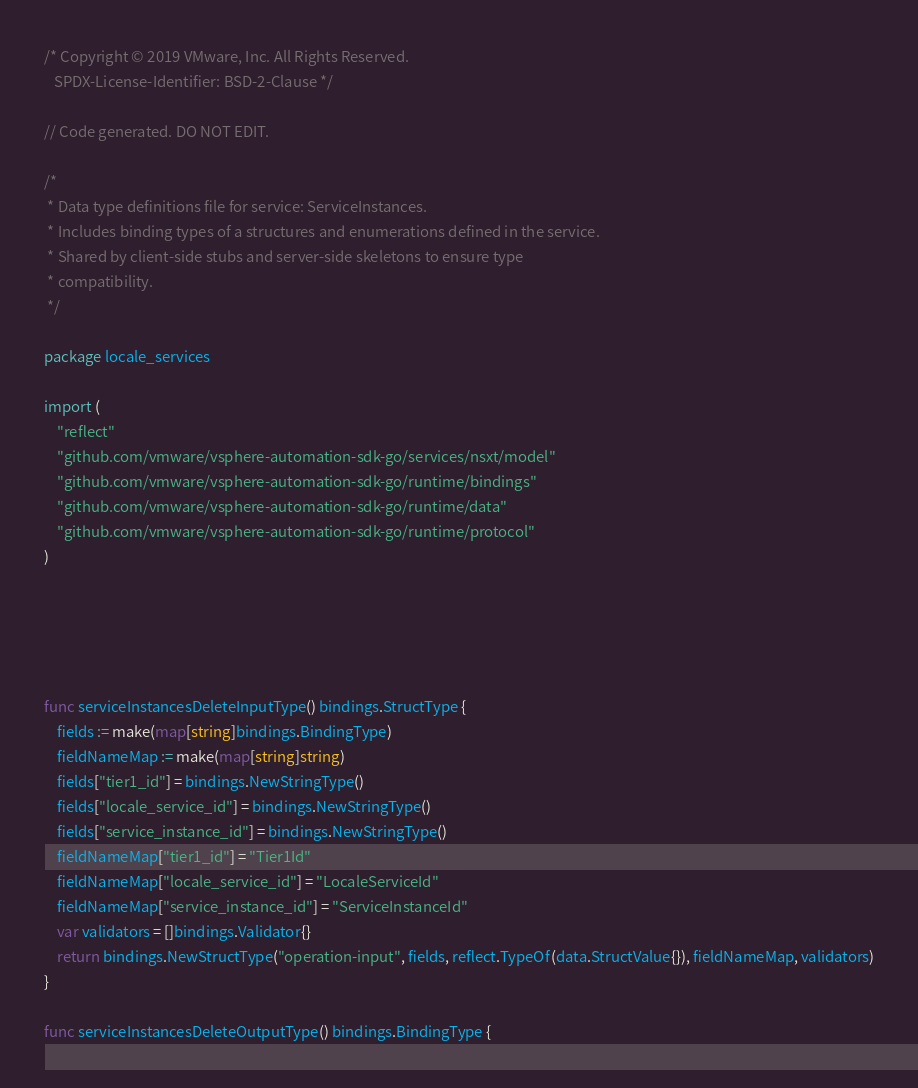<code> <loc_0><loc_0><loc_500><loc_500><_Go_>/* Copyright © 2019 VMware, Inc. All Rights Reserved.
   SPDX-License-Identifier: BSD-2-Clause */

// Code generated. DO NOT EDIT.

/*
 * Data type definitions file for service: ServiceInstances.
 * Includes binding types of a structures and enumerations defined in the service.
 * Shared by client-side stubs and server-side skeletons to ensure type
 * compatibility.
 */

package locale_services

import (
	"reflect"
	"github.com/vmware/vsphere-automation-sdk-go/services/nsxt/model"
	"github.com/vmware/vsphere-automation-sdk-go/runtime/bindings"
	"github.com/vmware/vsphere-automation-sdk-go/runtime/data"
	"github.com/vmware/vsphere-automation-sdk-go/runtime/protocol"
)





func serviceInstancesDeleteInputType() bindings.StructType {
	fields := make(map[string]bindings.BindingType)
	fieldNameMap := make(map[string]string)
	fields["tier1_id"] = bindings.NewStringType()
	fields["locale_service_id"] = bindings.NewStringType()
	fields["service_instance_id"] = bindings.NewStringType()
	fieldNameMap["tier1_id"] = "Tier1Id"
	fieldNameMap["locale_service_id"] = "LocaleServiceId"
	fieldNameMap["service_instance_id"] = "ServiceInstanceId"
	var validators = []bindings.Validator{}
	return bindings.NewStructType("operation-input", fields, reflect.TypeOf(data.StructValue{}), fieldNameMap, validators)
}

func serviceInstancesDeleteOutputType() bindings.BindingType {</code> 